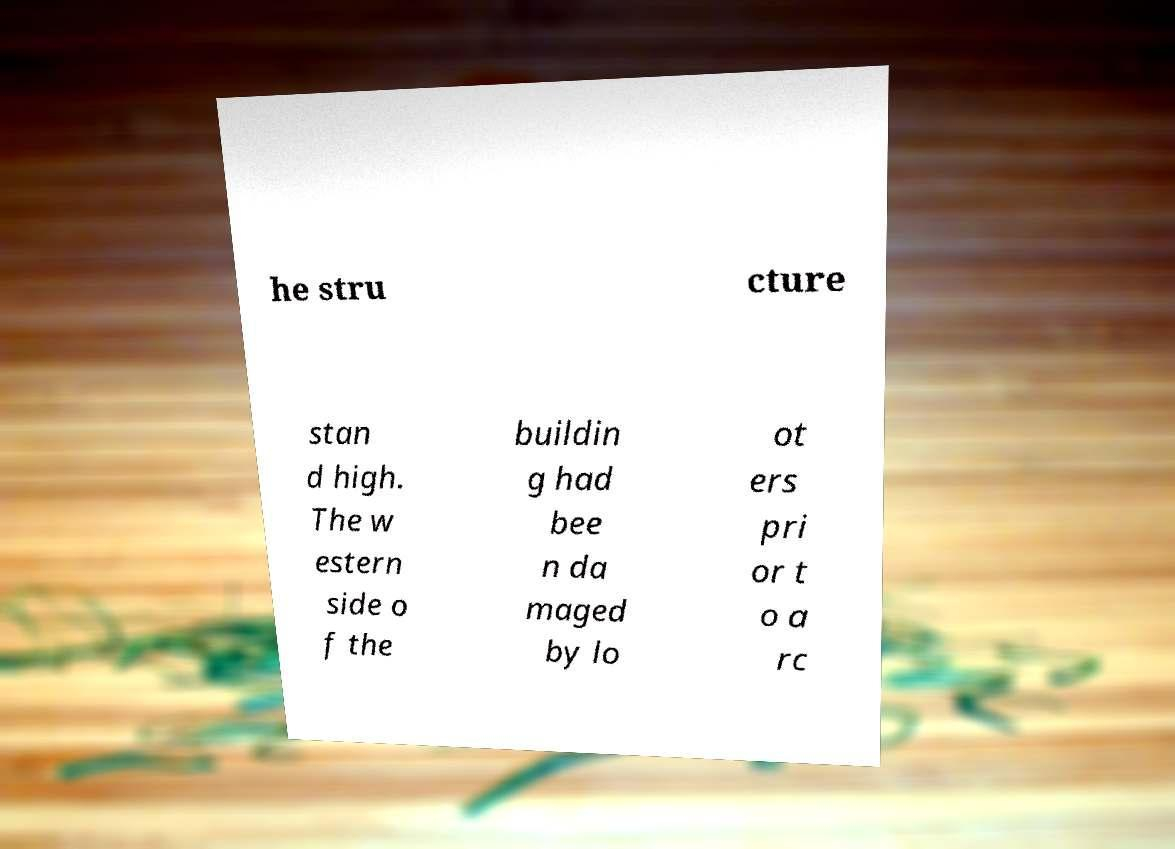Could you assist in decoding the text presented in this image and type it out clearly? he stru cture stan d high. The w estern side o f the buildin g had bee n da maged by lo ot ers pri or t o a rc 